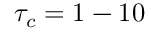<formula> <loc_0><loc_0><loc_500><loc_500>\tau _ { c } = 1 - 1 0</formula> 